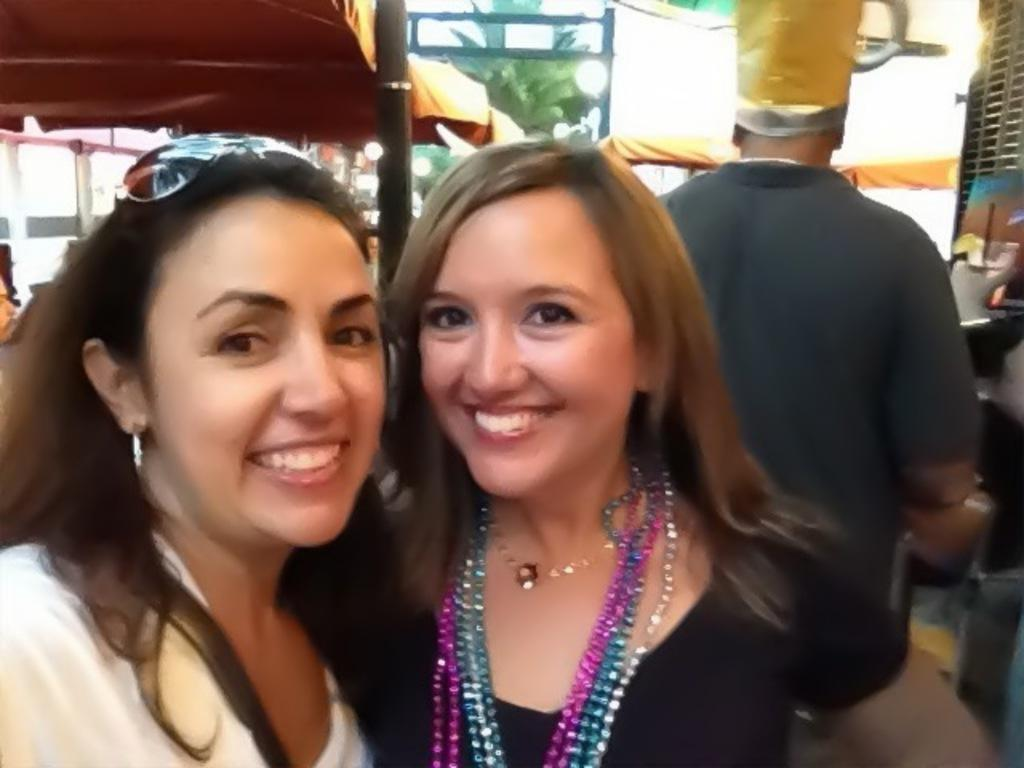How many women are in the image? There are two women in the image. What expression do the women have? The women are smiling. What can be seen in the background of the image? There are tents and trees in the background of the image. Is there anyone else present in the image besides the two women? Yes, there is another person standing to the right of the women. How would you describe the background of the image? The background is blurry. What type of nail is being used by the women in the image? There is no nail visible in the image, and the women are not using any tools. How many stars can be seen in the image? There are no stars visible in the image; it is set in an outdoor environment with tents and trees. 